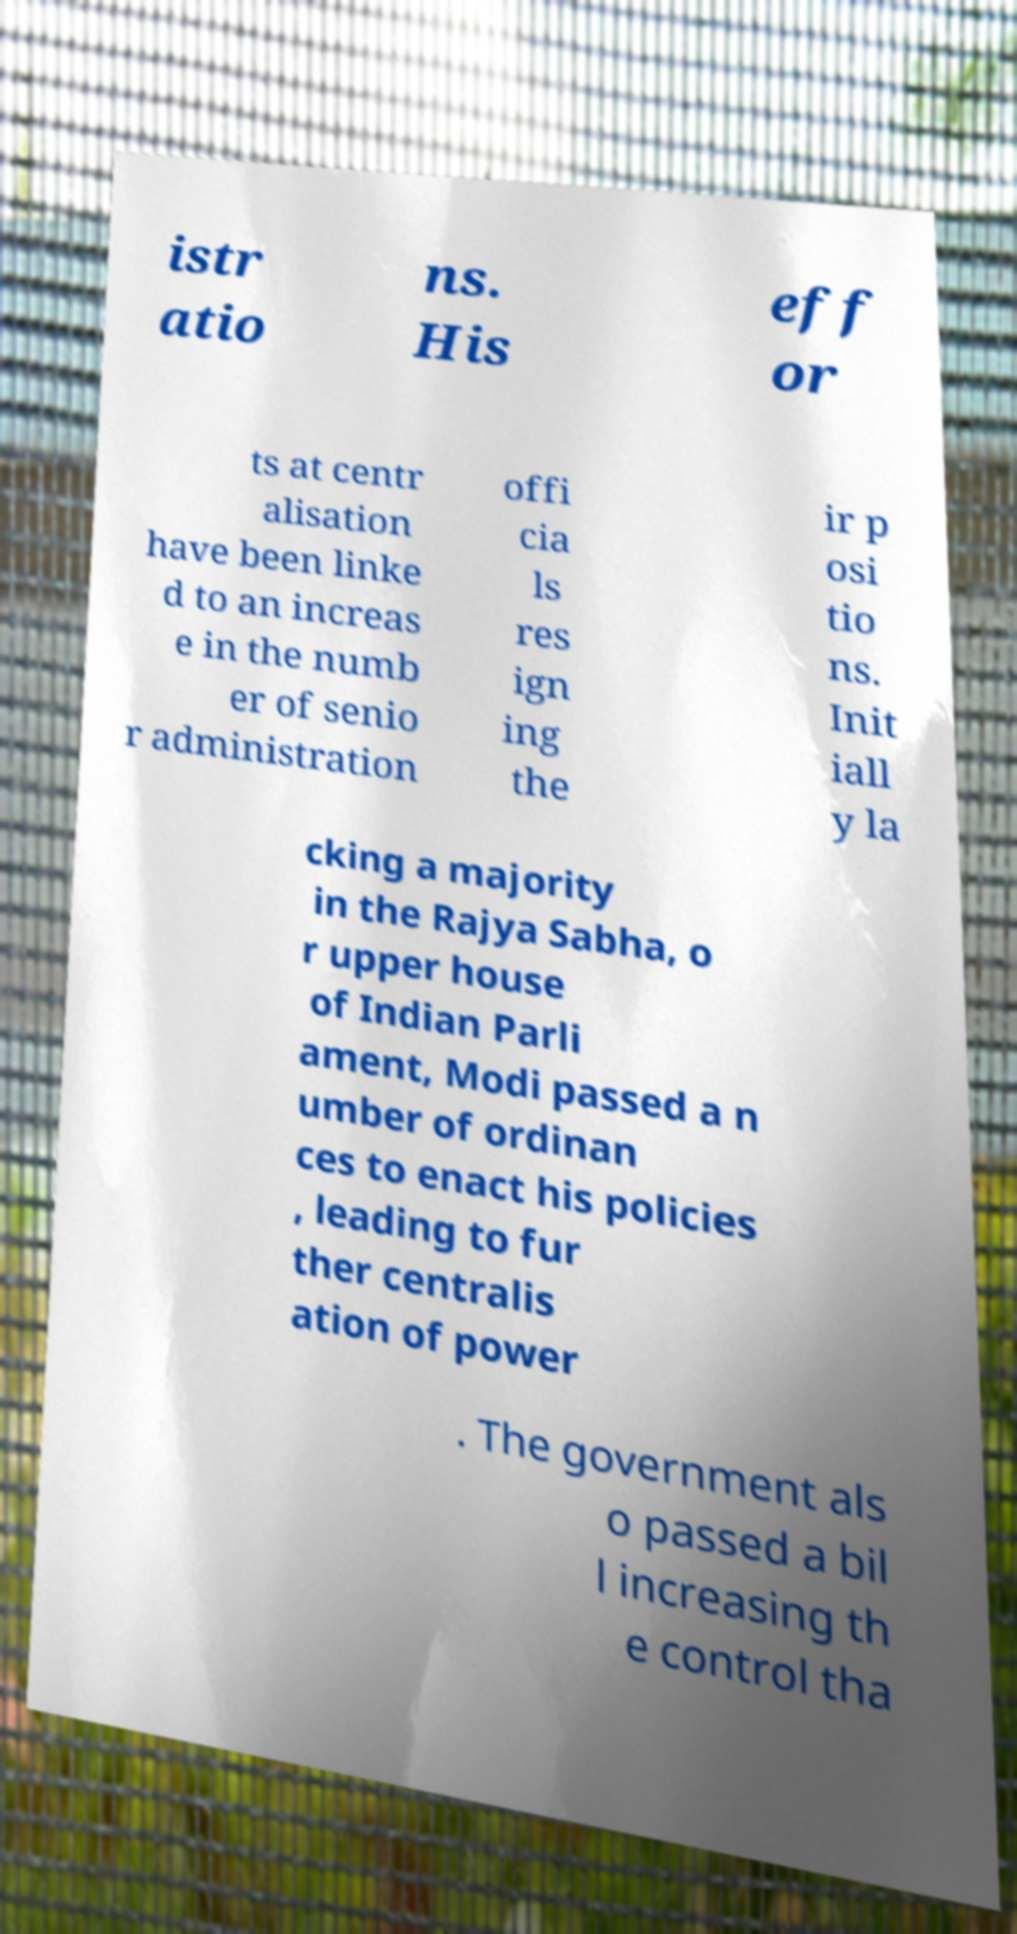Could you extract and type out the text from this image? istr atio ns. His eff or ts at centr alisation have been linke d to an increas e in the numb er of senio r administration offi cia ls res ign ing the ir p osi tio ns. Init iall y la cking a majority in the Rajya Sabha, o r upper house of Indian Parli ament, Modi passed a n umber of ordinan ces to enact his policies , leading to fur ther centralis ation of power . The government als o passed a bil l increasing th e control tha 